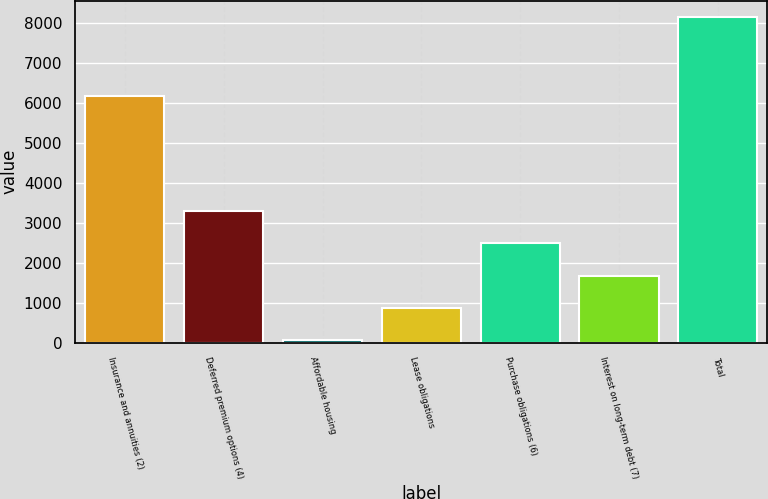Convert chart to OTSL. <chart><loc_0><loc_0><loc_500><loc_500><bar_chart><fcel>Insurance and annuities (2)<fcel>Deferred premium options (4)<fcel>Affordable housing<fcel>Lease obligations<fcel>Purchase obligations (6)<fcel>Interest on long-term debt (7)<fcel>Total<nl><fcel>6166<fcel>3299.8<fcel>59<fcel>869.2<fcel>2489.6<fcel>1679.4<fcel>8161<nl></chart> 